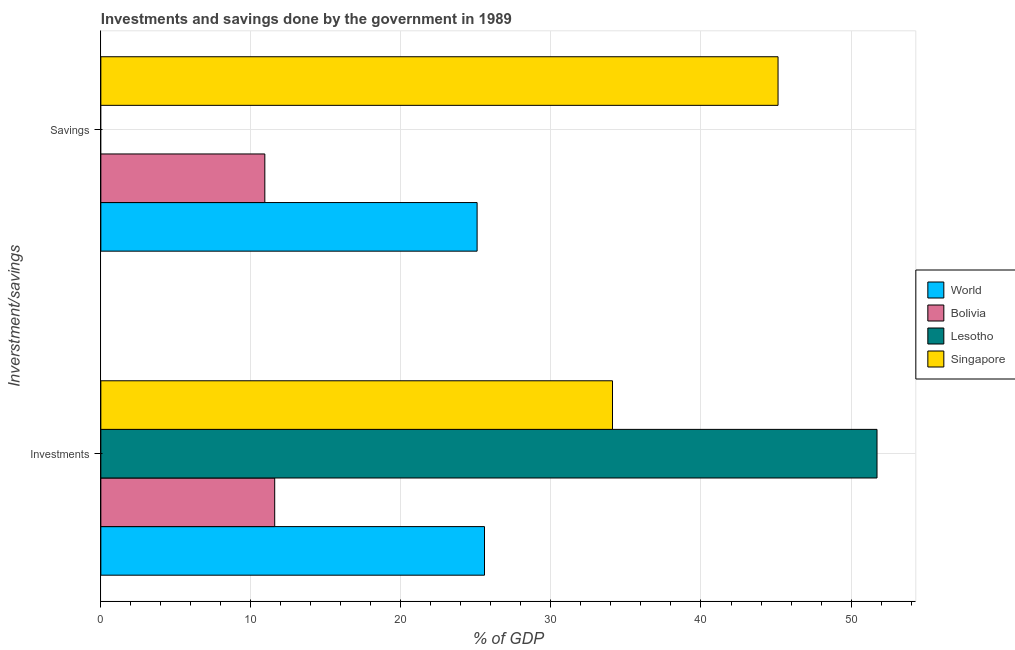How many different coloured bars are there?
Your response must be concise. 4. Are the number of bars per tick equal to the number of legend labels?
Offer a terse response. No. How many bars are there on the 2nd tick from the bottom?
Make the answer very short. 3. What is the label of the 2nd group of bars from the top?
Keep it short and to the point. Investments. What is the investments of government in World?
Offer a very short reply. 25.57. Across all countries, what is the maximum savings of government?
Ensure brevity in your answer.  45.14. Across all countries, what is the minimum savings of government?
Your response must be concise. 0. In which country was the savings of government maximum?
Offer a very short reply. Singapore. What is the total savings of government in the graph?
Give a very brief answer. 81.14. What is the difference between the savings of government in World and that in Singapore?
Your answer should be very brief. -20.06. What is the difference between the savings of government in Lesotho and the investments of government in Singapore?
Give a very brief answer. -34.1. What is the average investments of government per country?
Ensure brevity in your answer.  30.75. What is the difference between the savings of government and investments of government in Singapore?
Your answer should be very brief. 11.03. In how many countries, is the savings of government greater than 26 %?
Your answer should be compact. 1. What is the ratio of the investments of government in Bolivia to that in World?
Your response must be concise. 0.45. How many bars are there?
Your answer should be very brief. 7. Are all the bars in the graph horizontal?
Your answer should be compact. Yes. Are the values on the major ticks of X-axis written in scientific E-notation?
Offer a very short reply. No. Does the graph contain any zero values?
Your response must be concise. Yes. Does the graph contain grids?
Your response must be concise. Yes. Where does the legend appear in the graph?
Ensure brevity in your answer.  Center right. How many legend labels are there?
Your response must be concise. 4. What is the title of the graph?
Provide a short and direct response. Investments and savings done by the government in 1989. Does "Pakistan" appear as one of the legend labels in the graph?
Make the answer very short. No. What is the label or title of the X-axis?
Your answer should be compact. % of GDP. What is the label or title of the Y-axis?
Give a very brief answer. Inverstment/savings. What is the % of GDP of World in Investments?
Provide a succinct answer. 25.57. What is the % of GDP of Bolivia in Investments?
Ensure brevity in your answer.  11.59. What is the % of GDP in Lesotho in Investments?
Offer a terse response. 51.73. What is the % of GDP in Singapore in Investments?
Ensure brevity in your answer.  34.1. What is the % of GDP in World in Savings?
Give a very brief answer. 25.08. What is the % of GDP in Bolivia in Savings?
Provide a succinct answer. 10.93. What is the % of GDP of Singapore in Savings?
Your response must be concise. 45.14. Across all Inverstment/savings, what is the maximum % of GDP of World?
Your answer should be compact. 25.57. Across all Inverstment/savings, what is the maximum % of GDP of Bolivia?
Ensure brevity in your answer.  11.59. Across all Inverstment/savings, what is the maximum % of GDP of Lesotho?
Offer a very short reply. 51.73. Across all Inverstment/savings, what is the maximum % of GDP of Singapore?
Your answer should be compact. 45.14. Across all Inverstment/savings, what is the minimum % of GDP of World?
Your response must be concise. 25.08. Across all Inverstment/savings, what is the minimum % of GDP in Bolivia?
Ensure brevity in your answer.  10.93. Across all Inverstment/savings, what is the minimum % of GDP of Singapore?
Offer a terse response. 34.1. What is the total % of GDP of World in the graph?
Keep it short and to the point. 50.65. What is the total % of GDP of Bolivia in the graph?
Your answer should be very brief. 22.52. What is the total % of GDP in Lesotho in the graph?
Your response must be concise. 51.73. What is the total % of GDP in Singapore in the graph?
Keep it short and to the point. 79.24. What is the difference between the % of GDP of World in Investments and that in Savings?
Provide a short and direct response. 0.49. What is the difference between the % of GDP of Bolivia in Investments and that in Savings?
Keep it short and to the point. 0.66. What is the difference between the % of GDP in Singapore in Investments and that in Savings?
Offer a very short reply. -11.03. What is the difference between the % of GDP of World in Investments and the % of GDP of Bolivia in Savings?
Provide a succinct answer. 14.64. What is the difference between the % of GDP in World in Investments and the % of GDP in Singapore in Savings?
Provide a succinct answer. -19.56. What is the difference between the % of GDP in Bolivia in Investments and the % of GDP in Singapore in Savings?
Provide a short and direct response. -33.55. What is the difference between the % of GDP of Lesotho in Investments and the % of GDP of Singapore in Savings?
Provide a succinct answer. 6.6. What is the average % of GDP of World per Inverstment/savings?
Ensure brevity in your answer.  25.32. What is the average % of GDP in Bolivia per Inverstment/savings?
Provide a short and direct response. 11.26. What is the average % of GDP in Lesotho per Inverstment/savings?
Offer a very short reply. 25.87. What is the average % of GDP of Singapore per Inverstment/savings?
Your response must be concise. 39.62. What is the difference between the % of GDP in World and % of GDP in Bolivia in Investments?
Provide a short and direct response. 13.98. What is the difference between the % of GDP of World and % of GDP of Lesotho in Investments?
Your response must be concise. -26.16. What is the difference between the % of GDP in World and % of GDP in Singapore in Investments?
Keep it short and to the point. -8.53. What is the difference between the % of GDP of Bolivia and % of GDP of Lesotho in Investments?
Your answer should be compact. -40.14. What is the difference between the % of GDP in Bolivia and % of GDP in Singapore in Investments?
Provide a short and direct response. -22.51. What is the difference between the % of GDP of Lesotho and % of GDP of Singapore in Investments?
Give a very brief answer. 17.63. What is the difference between the % of GDP of World and % of GDP of Bolivia in Savings?
Ensure brevity in your answer.  14.15. What is the difference between the % of GDP in World and % of GDP in Singapore in Savings?
Keep it short and to the point. -20.06. What is the difference between the % of GDP in Bolivia and % of GDP in Singapore in Savings?
Your answer should be very brief. -34.21. What is the ratio of the % of GDP in World in Investments to that in Savings?
Ensure brevity in your answer.  1.02. What is the ratio of the % of GDP in Bolivia in Investments to that in Savings?
Your response must be concise. 1.06. What is the ratio of the % of GDP in Singapore in Investments to that in Savings?
Ensure brevity in your answer.  0.76. What is the difference between the highest and the second highest % of GDP of World?
Give a very brief answer. 0.49. What is the difference between the highest and the second highest % of GDP of Bolivia?
Provide a succinct answer. 0.66. What is the difference between the highest and the second highest % of GDP in Singapore?
Your answer should be compact. 11.03. What is the difference between the highest and the lowest % of GDP of World?
Make the answer very short. 0.49. What is the difference between the highest and the lowest % of GDP of Bolivia?
Offer a very short reply. 0.66. What is the difference between the highest and the lowest % of GDP in Lesotho?
Your response must be concise. 51.73. What is the difference between the highest and the lowest % of GDP of Singapore?
Offer a terse response. 11.03. 